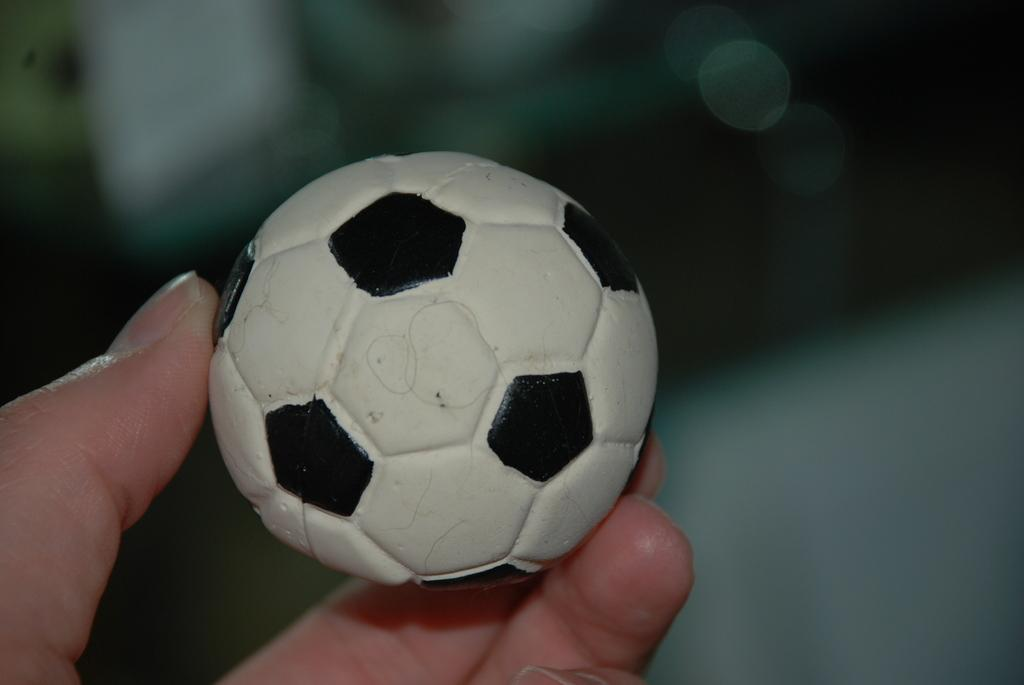What is being held by the hand in the image? The hand is holding a small ball. Can you describe the appearance of the ball? The ball is white and black in color. How many brothers does the daughter in the image have? There is no daughter or reference to family members in the image. 